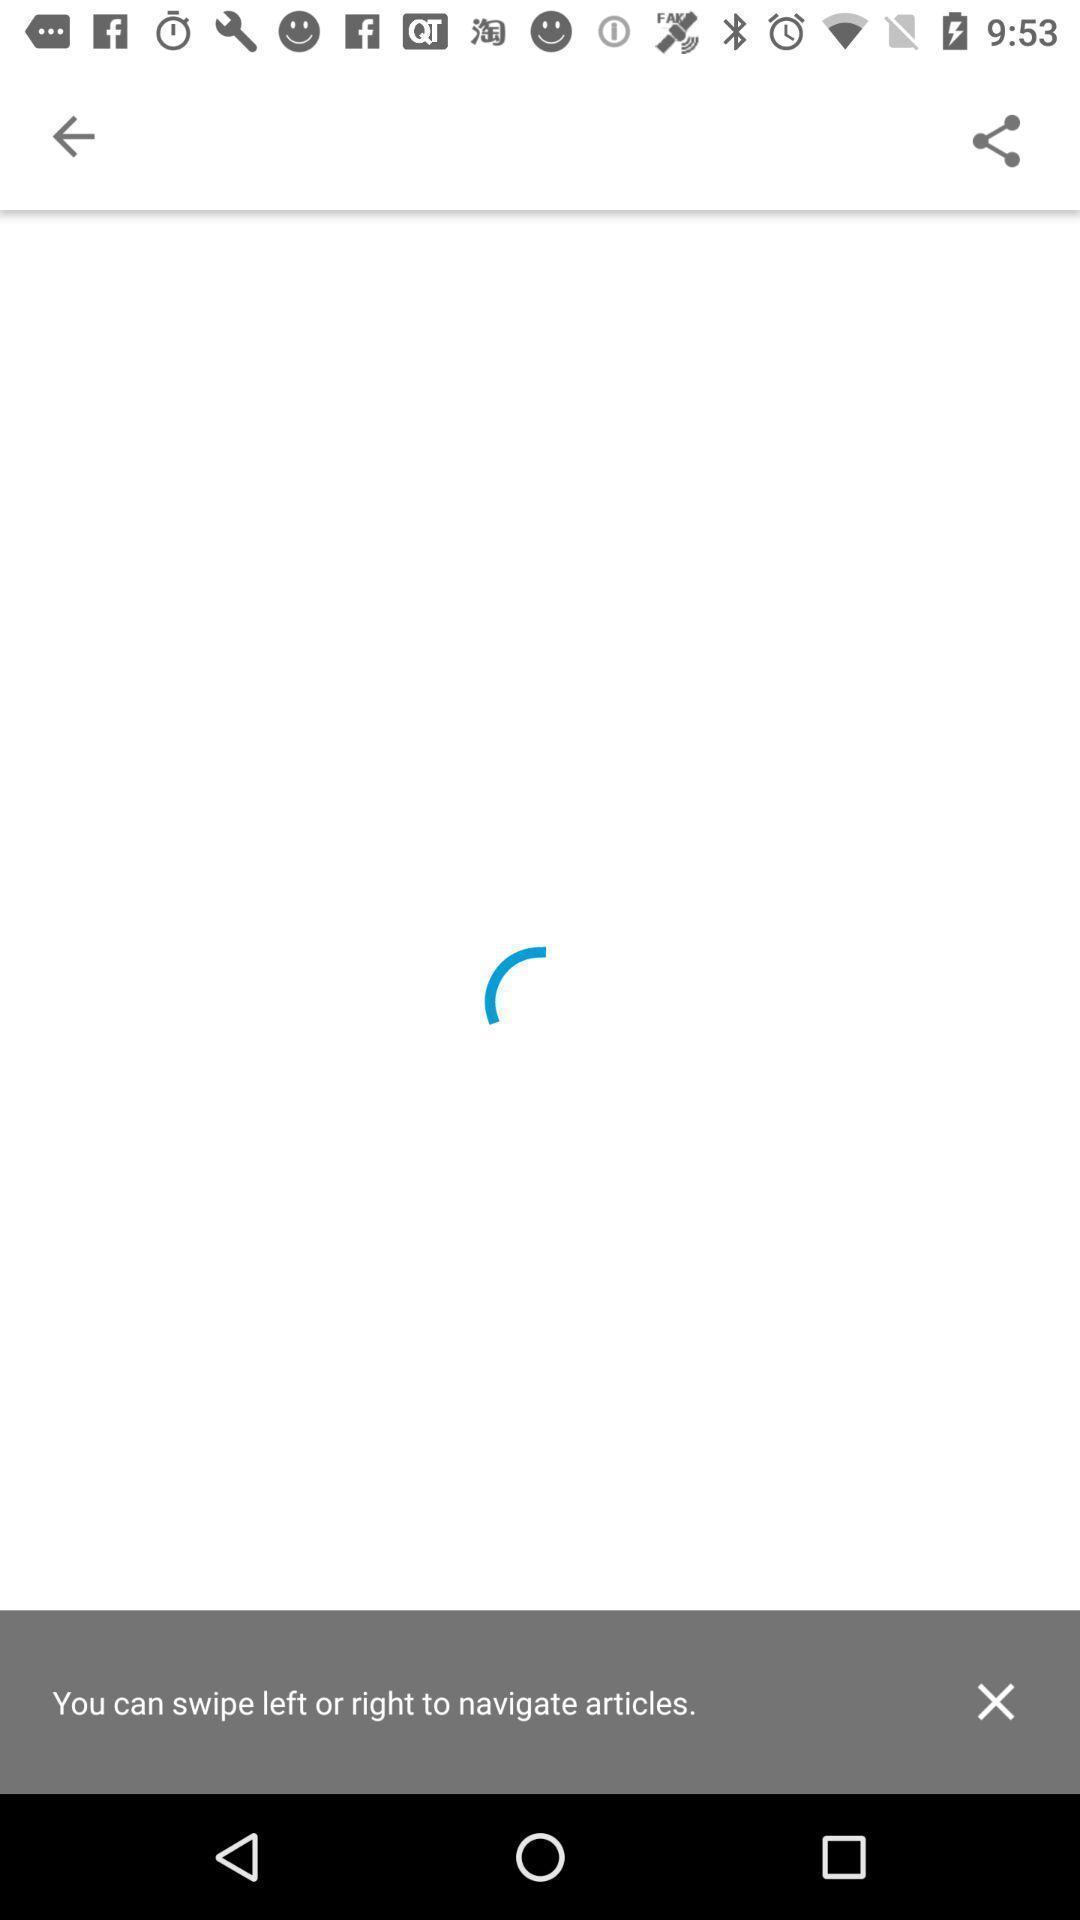Give me a summary of this screen capture. Screen that shows loading of a page. 